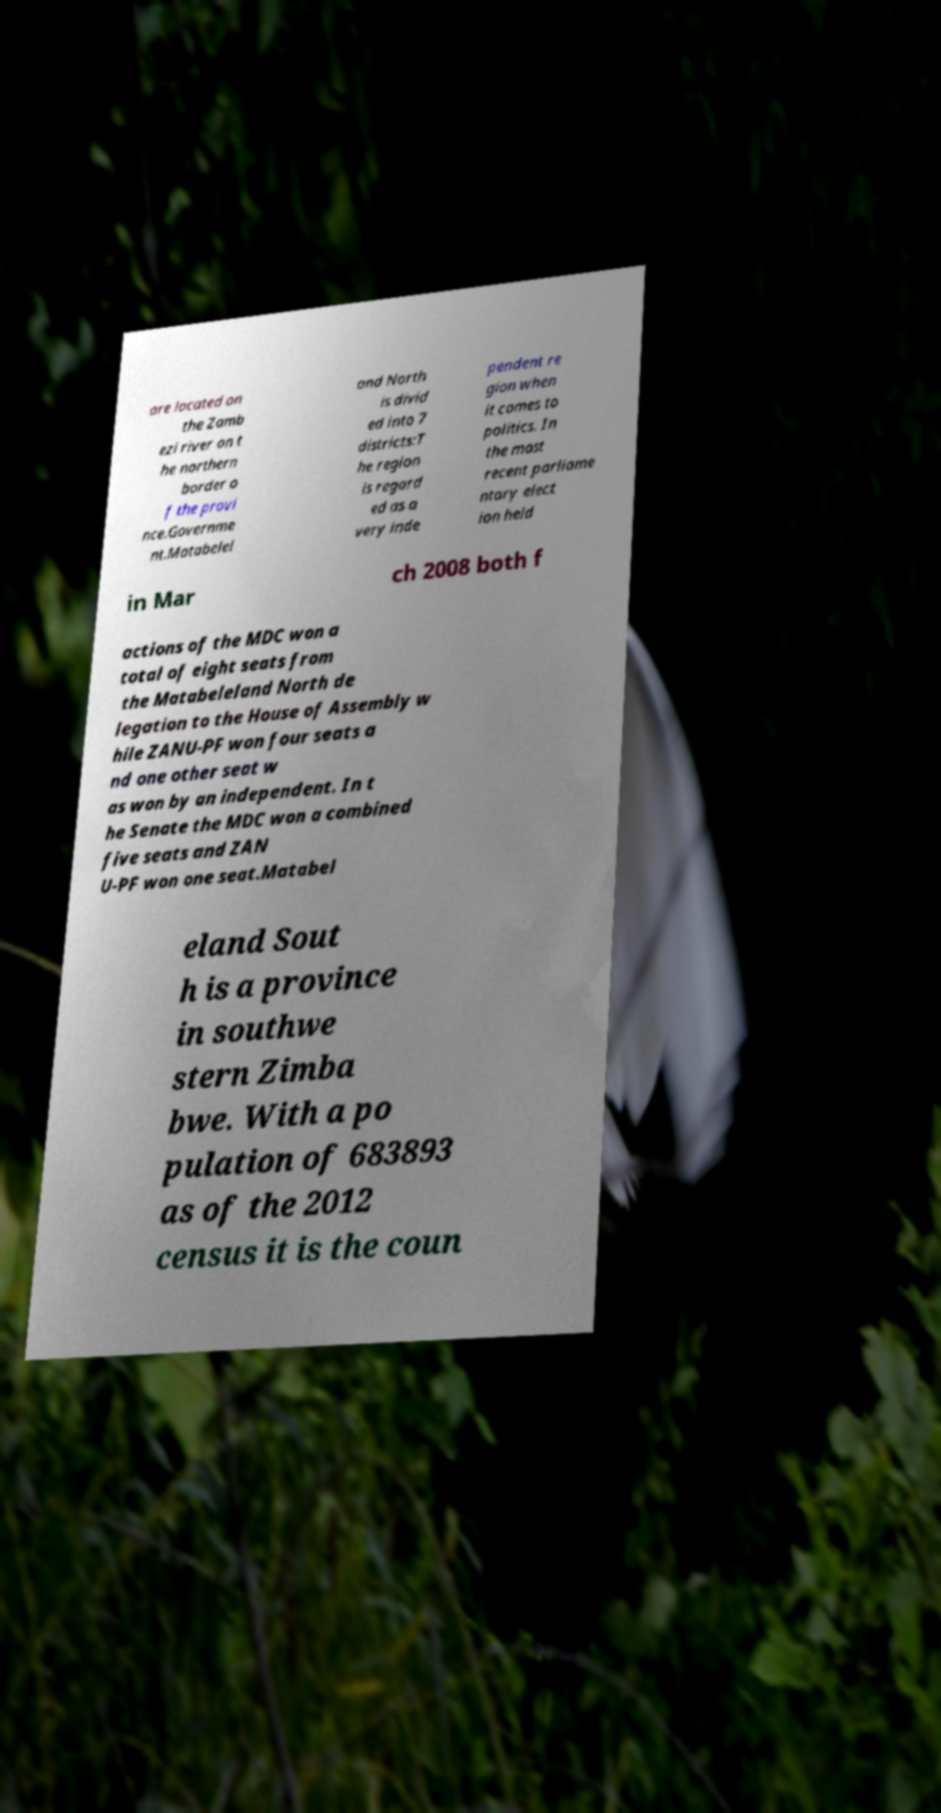Please read and relay the text visible in this image. What does it say? are located on the Zamb ezi river on t he northern border o f the provi nce.Governme nt.Matabelel and North is divid ed into 7 districts:T he region is regard ed as a very inde pendent re gion when it comes to politics. In the most recent parliame ntary elect ion held in Mar ch 2008 both f actions of the MDC won a total of eight seats from the Matabeleland North de legation to the House of Assembly w hile ZANU-PF won four seats a nd one other seat w as won by an independent. In t he Senate the MDC won a combined five seats and ZAN U-PF won one seat.Matabel eland Sout h is a province in southwe stern Zimba bwe. With a po pulation of 683893 as of the 2012 census it is the coun 